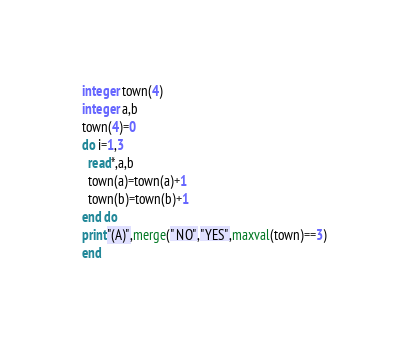<code> <loc_0><loc_0><loc_500><loc_500><_FORTRAN_>integer town(4)
integer a,b
town(4)=0
do i=1,3
  read*,a,b
  town(a)=town(a)+1
  town(b)=town(b)+1
end do
print"(A)",merge(" NO","YES",maxval(town)==3)
end</code> 